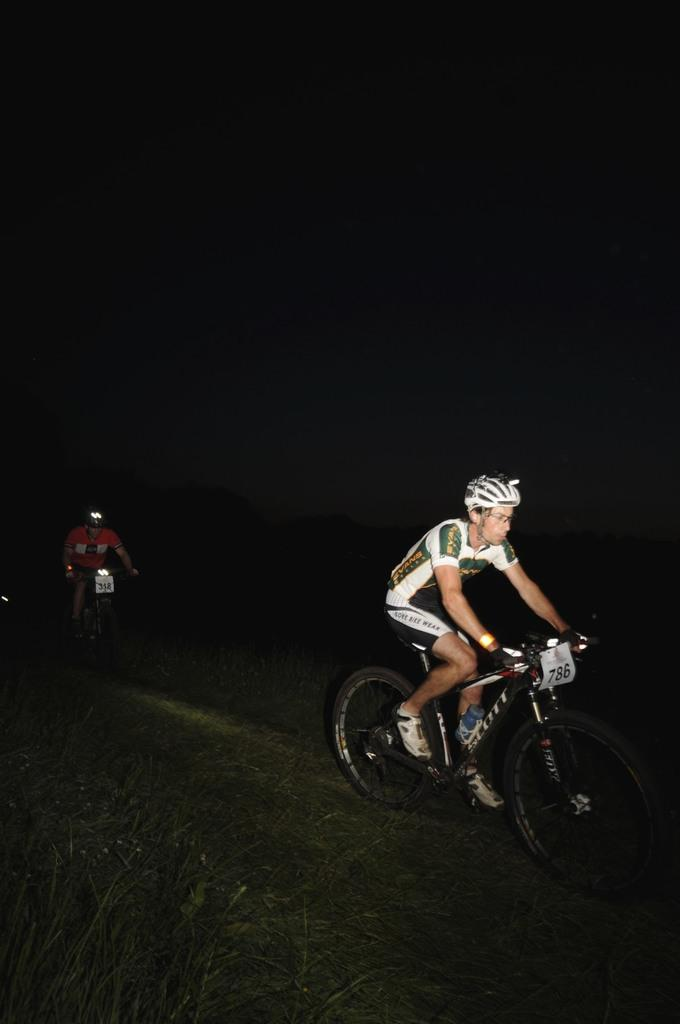What are the men in the image doing? The men in the image are riding bicycles. What safety precaution are the men taking while riding bicycles? The men are wearing helmets. What can be observed about the lighting conditions in the image? The background of the image is dark. What type of arm can be seen holding a bottle in the image? There is no arm or bottle present in the image; it features men riding bicycles while wearing helmets. Is there a ship visible in the image? No, there is no ship present in the image. 